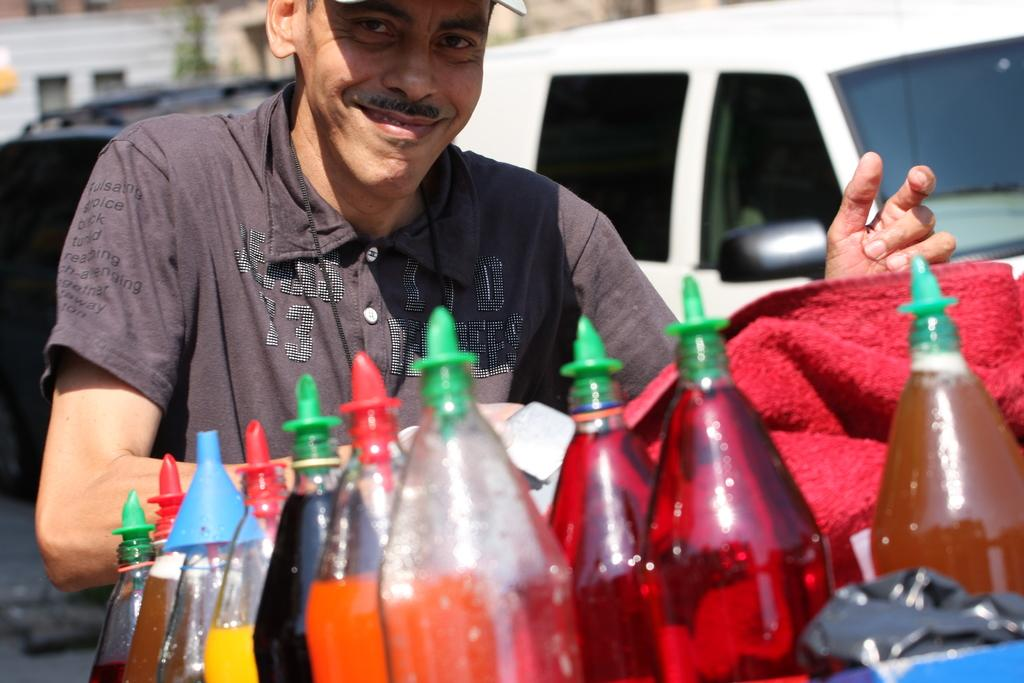What is present in the image? There is a man in the image. What is the man doing in the image? The man is standing in the image. What objects are in front of the man? There are juice bottles in front of the man. How does the man walk while holding the juice bottles in the image? The man is not walking in the image; he is standing. Additionally, there is no indication that he is holding any juice bottles. 